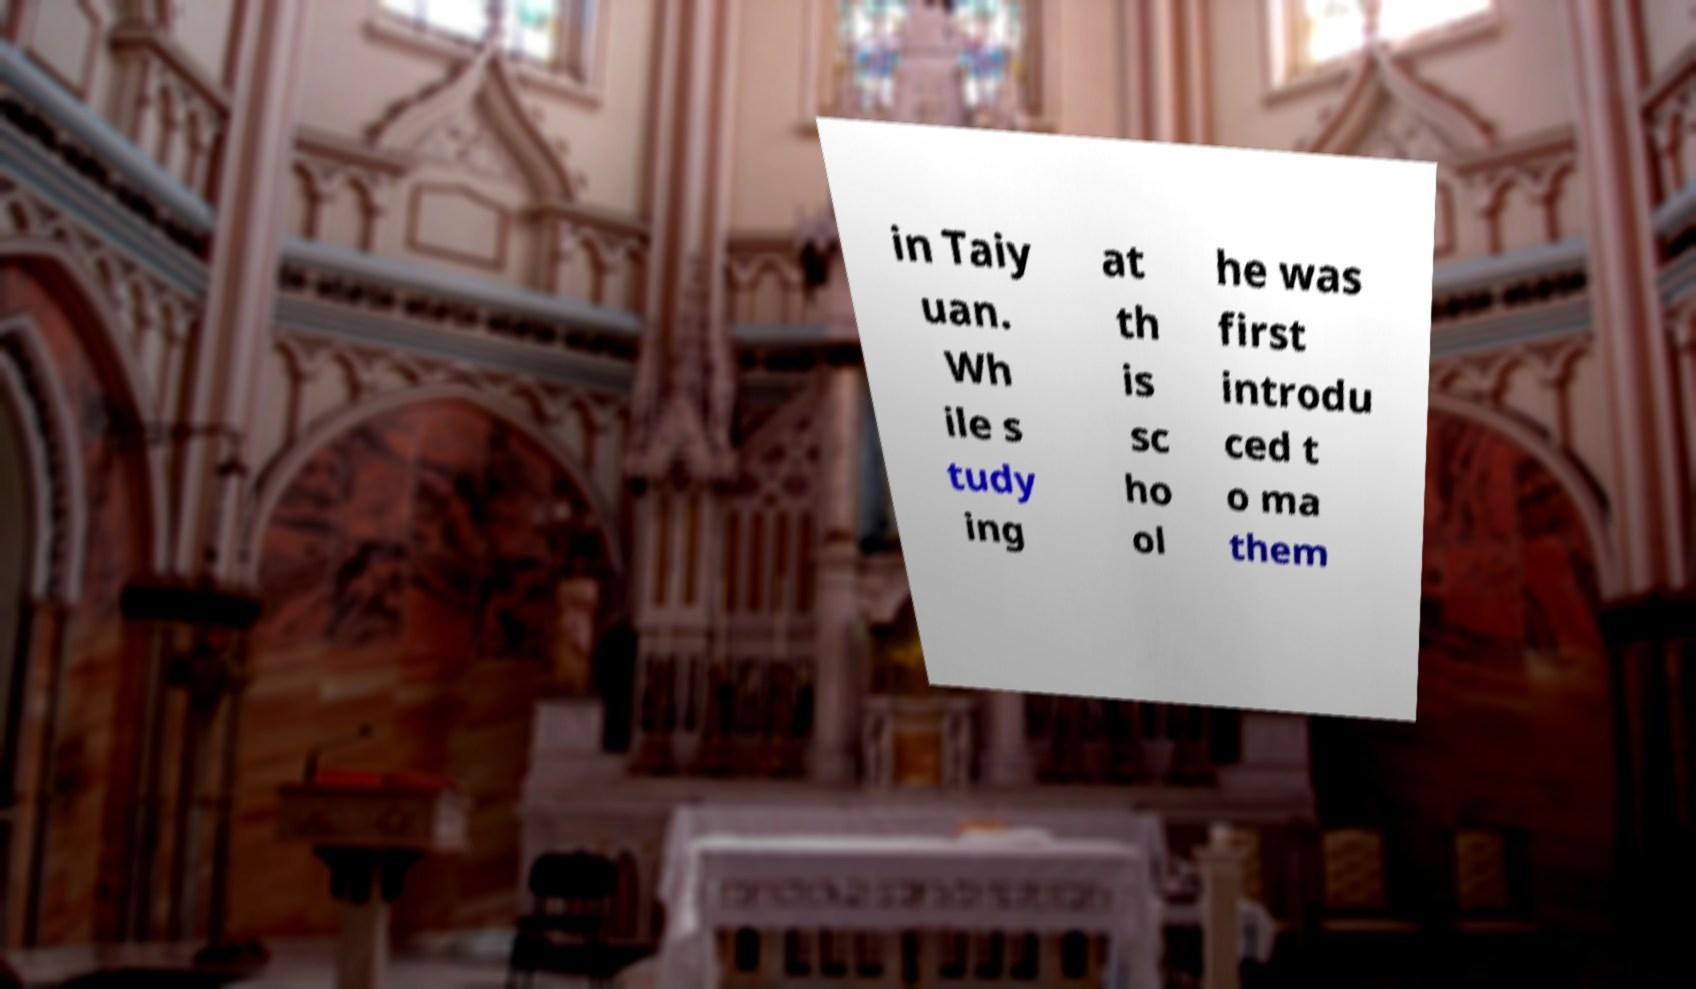Could you extract and type out the text from this image? in Taiy uan. Wh ile s tudy ing at th is sc ho ol he was first introdu ced t o ma them 